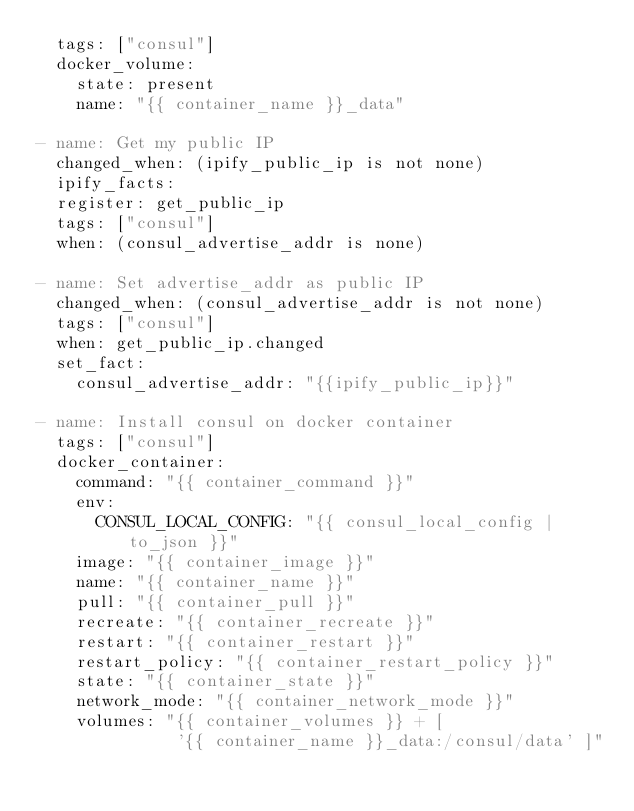<code> <loc_0><loc_0><loc_500><loc_500><_YAML_>  tags: ["consul"]
  docker_volume:
    state: present
    name: "{{ container_name }}_data"

- name: Get my public IP
  changed_when: (ipify_public_ip is not none)
  ipify_facts:
  register: get_public_ip
  tags: ["consul"]
  when: (consul_advertise_addr is none)

- name: Set advertise_addr as public IP
  changed_when: (consul_advertise_addr is not none)
  tags: ["consul"]
  when: get_public_ip.changed
  set_fact:
    consul_advertise_addr: "{{ipify_public_ip}}"

- name: Install consul on docker container
  tags: ["consul"]
  docker_container:
    command: "{{ container_command }}"
    env:
      CONSUL_LOCAL_CONFIG: "{{ consul_local_config | to_json }}"
    image: "{{ container_image }}"
    name: "{{ container_name }}"
    pull: "{{ container_pull }}"
    recreate: "{{ container_recreate }}"
    restart: "{{ container_restart }}"
    restart_policy: "{{ container_restart_policy }}"
    state: "{{ container_state }}"
    network_mode: "{{ container_network_mode }}"
    volumes: "{{ container_volumes }} + [
              '{{ container_name }}_data:/consul/data' ]"
</code> 